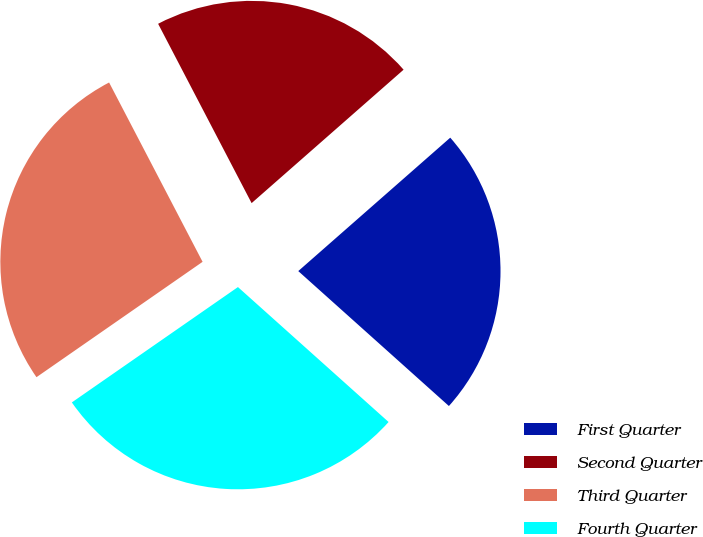Convert chart. <chart><loc_0><loc_0><loc_500><loc_500><pie_chart><fcel>First Quarter<fcel>Second Quarter<fcel>Third Quarter<fcel>Fourth Quarter<nl><fcel>23.09%<fcel>21.18%<fcel>27.01%<fcel>28.71%<nl></chart> 